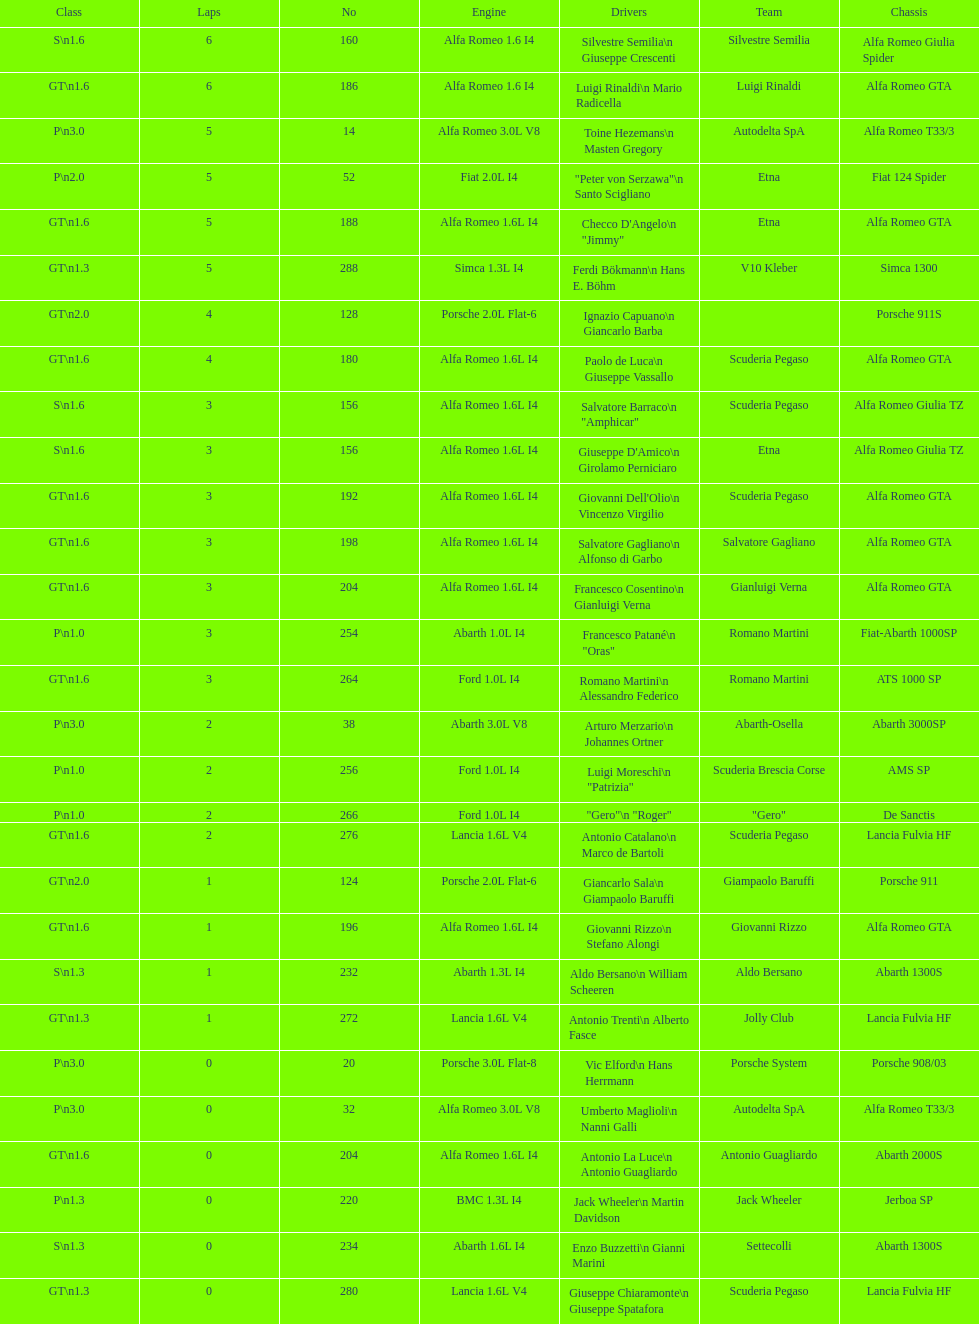Name the only american who did not finish the race. Masten Gregory. 